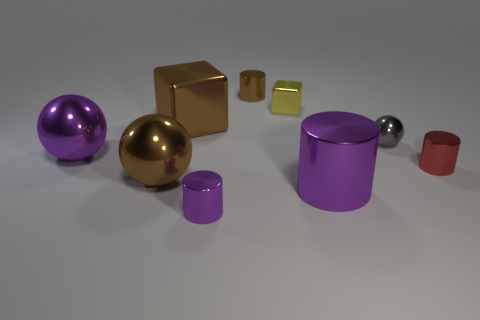Is the number of brown shiny objects right of the gray metallic ball less than the number of big purple cylinders that are behind the brown metal ball?
Your answer should be very brief. No. What is the color of the large metallic thing that is the same shape as the tiny red shiny thing?
Your answer should be compact. Purple. How many tiny objects are both right of the yellow metal block and to the left of the tiny yellow metal cube?
Provide a succinct answer. 0. Are there more large shiny things that are behind the tiny sphere than small yellow blocks on the right side of the small red metal cylinder?
Make the answer very short. Yes. The brown cylinder is what size?
Give a very brief answer. Small. Is there a tiny purple metal thing that has the same shape as the tiny yellow shiny thing?
Make the answer very short. No. Do the red shiny object and the big purple shiny object that is to the right of the tiny purple shiny cylinder have the same shape?
Your answer should be compact. Yes. There is a thing that is in front of the yellow shiny block and behind the small sphere; what size is it?
Your answer should be compact. Large. What number of brown shiny objects are there?
Offer a very short reply. 3. There is a gray object that is the same size as the yellow block; what is its material?
Offer a very short reply. Metal. 